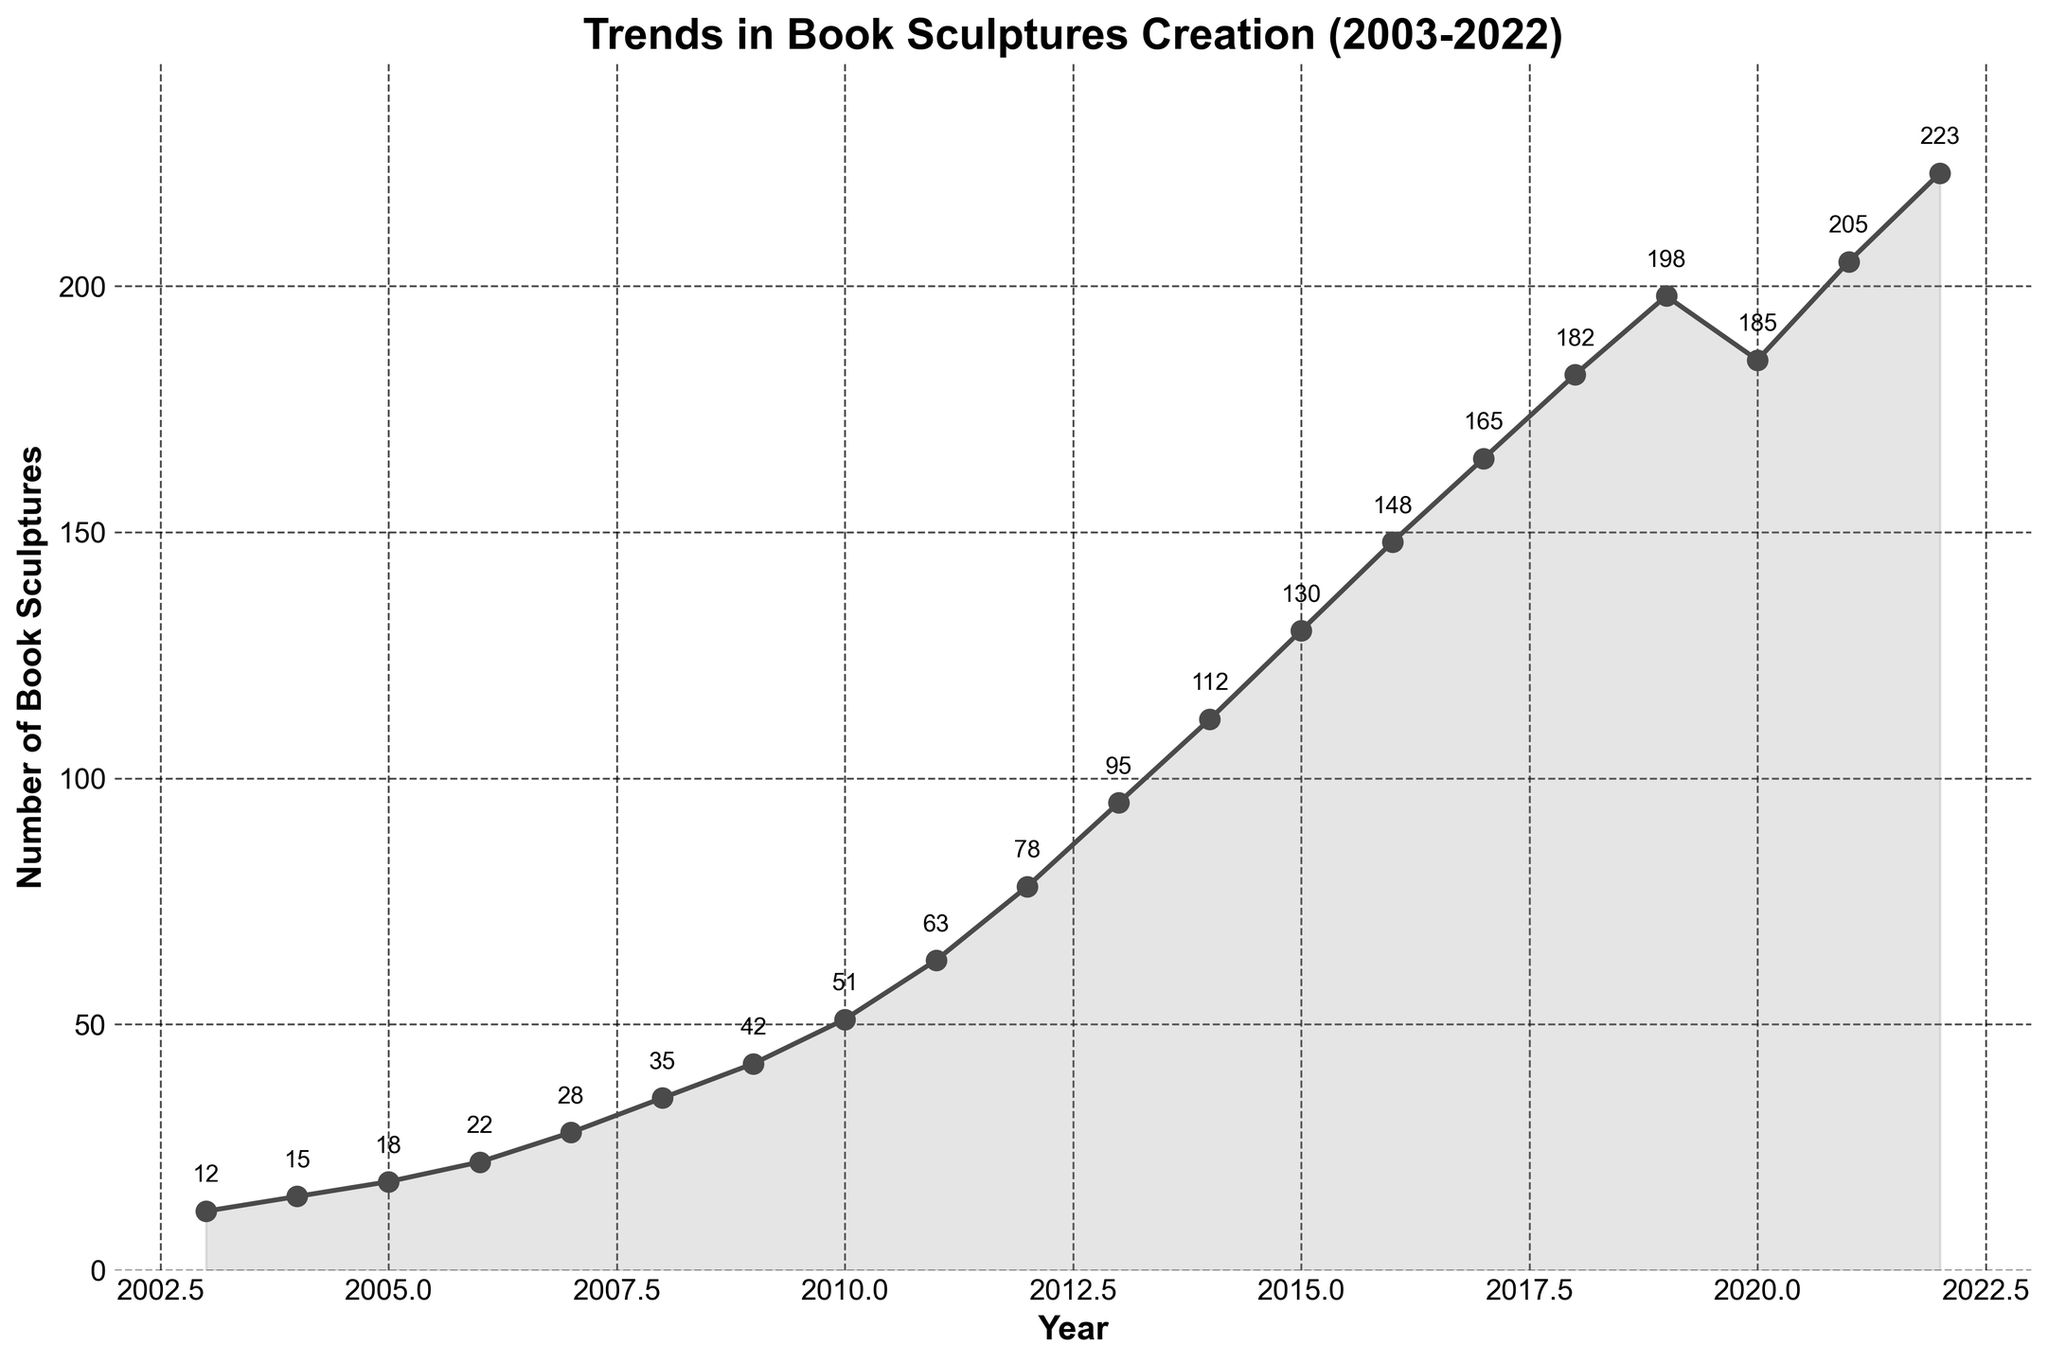Which year had the highest number of book sculptures created? The year with the highest number of book sculptures can be identified by finding the peak point in the line chart. The peak occurs at the year 2022.
Answer: 2022 What was the total number of book sculptures created between 2003 and 2007? To find the total, sum the values for the years from 2003 to 2007. 12 (2003) + 15 (2004) + 18 (2005) + 22 (2006) + 28 (2007) = 95
Answer: 95 How many more book sculptures were created in 2022 compared to 2003? Subtract the number of book sculptures in 2003 from those in 2022. 223 (2022) - 12 (2003) = 211
Answer: 211 In which year did the number of book sculptures increase the most compared to the previous year? Find the year where the difference between the book sculptures created in one year and the previous year is the highest. The largest increase occurs between 2019 (198) and 2021 (205). So the year is 2021.
Answer: 2021 Was there any year where the number of book sculptures created decreased compared to the previous year? Look for a downward trend or a dip in the line chart. The only dip occurs between 2019 (198) and 2020 (185).
Answer: Yes What is the average number of book sculptures created annually between 2003 and 2022? To find the average, sum all the values and divide by the number of years. Total: 12 + 15 + 18 + 22 + 28 + 35 + 42 + 51 + 63 + 78 + 95 + 112 + 130 + 148 + 165 + 182 + 198 + 185 + 205 + 223 = 2009. Divide by the number of years (20): 2009 / 20 = 100.45
Answer: 100.45 Compare the number of book sculptures created in 2010 and 2015. Which year had more and by how much? Subtract the number of book sculptures created in 2010 from those in 2015. 130 (2015) - 51 (2010) = 79. So, 2015 had 79 more sculptures.
Answer: 2015 by 79 